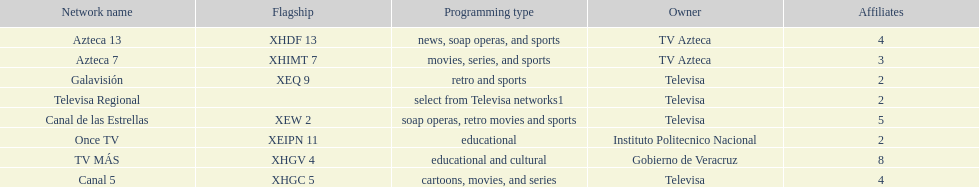Who has the most number of affiliates? TV MÁS. 